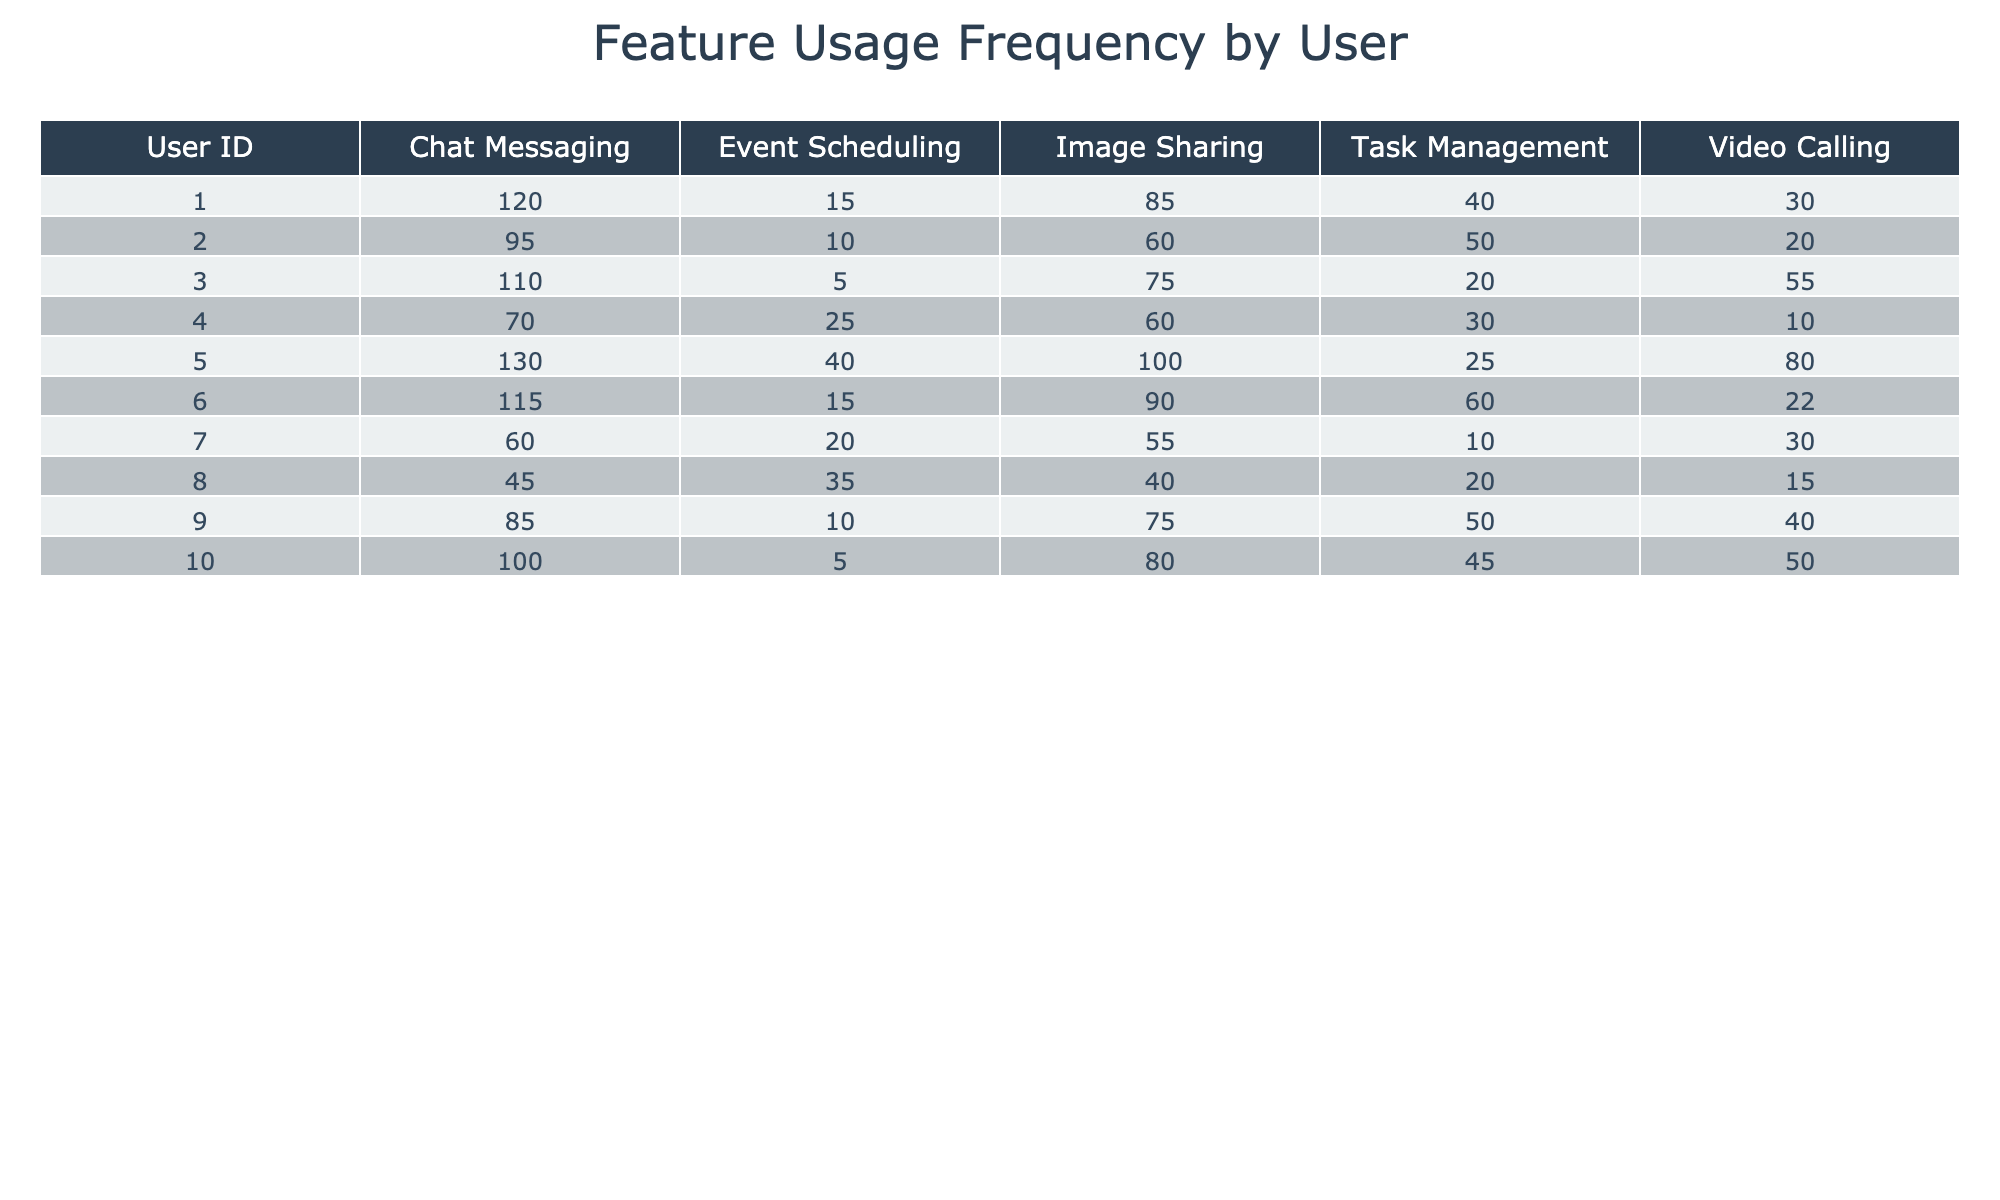What is the maximum usage frequency for Chat Messaging? Looking at the "Chat Messaging" row across all users, the maximum value is 130 from User_ID 5.
Answer: 130 Which user has the highest frequency for Video Calling? In the "Video Calling" column, User_ID 3 has the highest frequency of 55.
Answer: 55 What is the usage frequency for Image Sharing by User_ID 6? From the "Image Sharing" column, User_ID 6 has a frequency of 90.
Answer: 90 Is there any user who never used Event Scheduling? By checking the "Event Scheduling" column, User_ID 3 has the lowest frequency of 5, and all other users have higher usage. So, no user has a usage frequency of zero.
Answer: No Calculate the average usage frequency for Task Management across all users. Summing the "Task Management" values gives 40 + 50 + 20 + 30 + 25 + 60 + 10 + 20 + 50 + 45 = 410. Since there are 10 users, the average usage frequency is 410/10 = 41.
Answer: 41 Which feature is commonly used more than 75 times by at least 5 users? Counting the frequencies in each column, Chat Messaging is used more than 75 times by Users 1, 2, 3, 5, and 6 (5 users).
Answer: Chat Messaging What is the difference in usage frequency between the highest and lowest users of Event Scheduling? The highest usage frequency for Event Scheduling is 40 (User_ID 5), and the lowest is 5 (User_ID 3). Therefore, the difference is 40 - 5 = 35.
Answer: 35 Which user had the last active date of 2023-10-02? By checking the "Last Active Date" row, User_IDs 2, 3, 5, and 6 all had their last active date on 2023-10-02.
Answer: User_ID 2, 3, 5, 6 Identify the feature with the lowest usage frequency across all users. Checking each feature, the lowest usage frequency is for Event Scheduling, with the value 5 (by User_ID 3).
Answer: Event Scheduling Which user has the highest overall usage frequency across all features? By summing the usage frequencies for each user, User_ID 5 has the highest total of 375 (130 + 100 + 80 + 40 + 25).
Answer: User_ID 5 